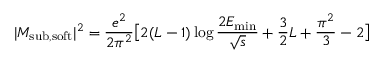<formula> <loc_0><loc_0><loc_500><loc_500>| M _ { s u b , s o f t } | ^ { 2 } = \frac { e ^ { 2 } } { 2 \pi ^ { 2 } } \left [ 2 ( L - 1 ) \log \frac { 2 E _ { \min } } { \sqrt { s } } + \frac { 3 } { 2 } L + \frac { \pi ^ { 2 } } { 3 } - 2 \right ]</formula> 